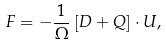<formula> <loc_0><loc_0><loc_500><loc_500>F = - \frac { 1 } { \Omega } \left [ D + Q \right ] \cdot U ,</formula> 